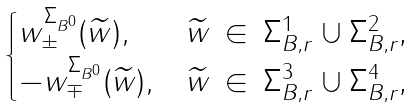Convert formula to latex. <formula><loc_0><loc_0><loc_500><loc_500>\begin{cases} w ^ { \Sigma _ { B ^ { 0 } } } _ { \pm } ( \widetilde { w } ) , & \text {$\widetilde{w} \, \in \, \Sigma_{B,r}^{1} \cup \Sigma_{B,r}^{2}$,} \\ - w ^ { \Sigma _ { B ^ { 0 } } } _ { \mp } ( \widetilde { w } ) , & \text {$\widetilde{w} \, \in \, \Sigma_{B,r}^{3} \cup \Sigma_{B,r}^{4}$,} \end{cases}</formula> 